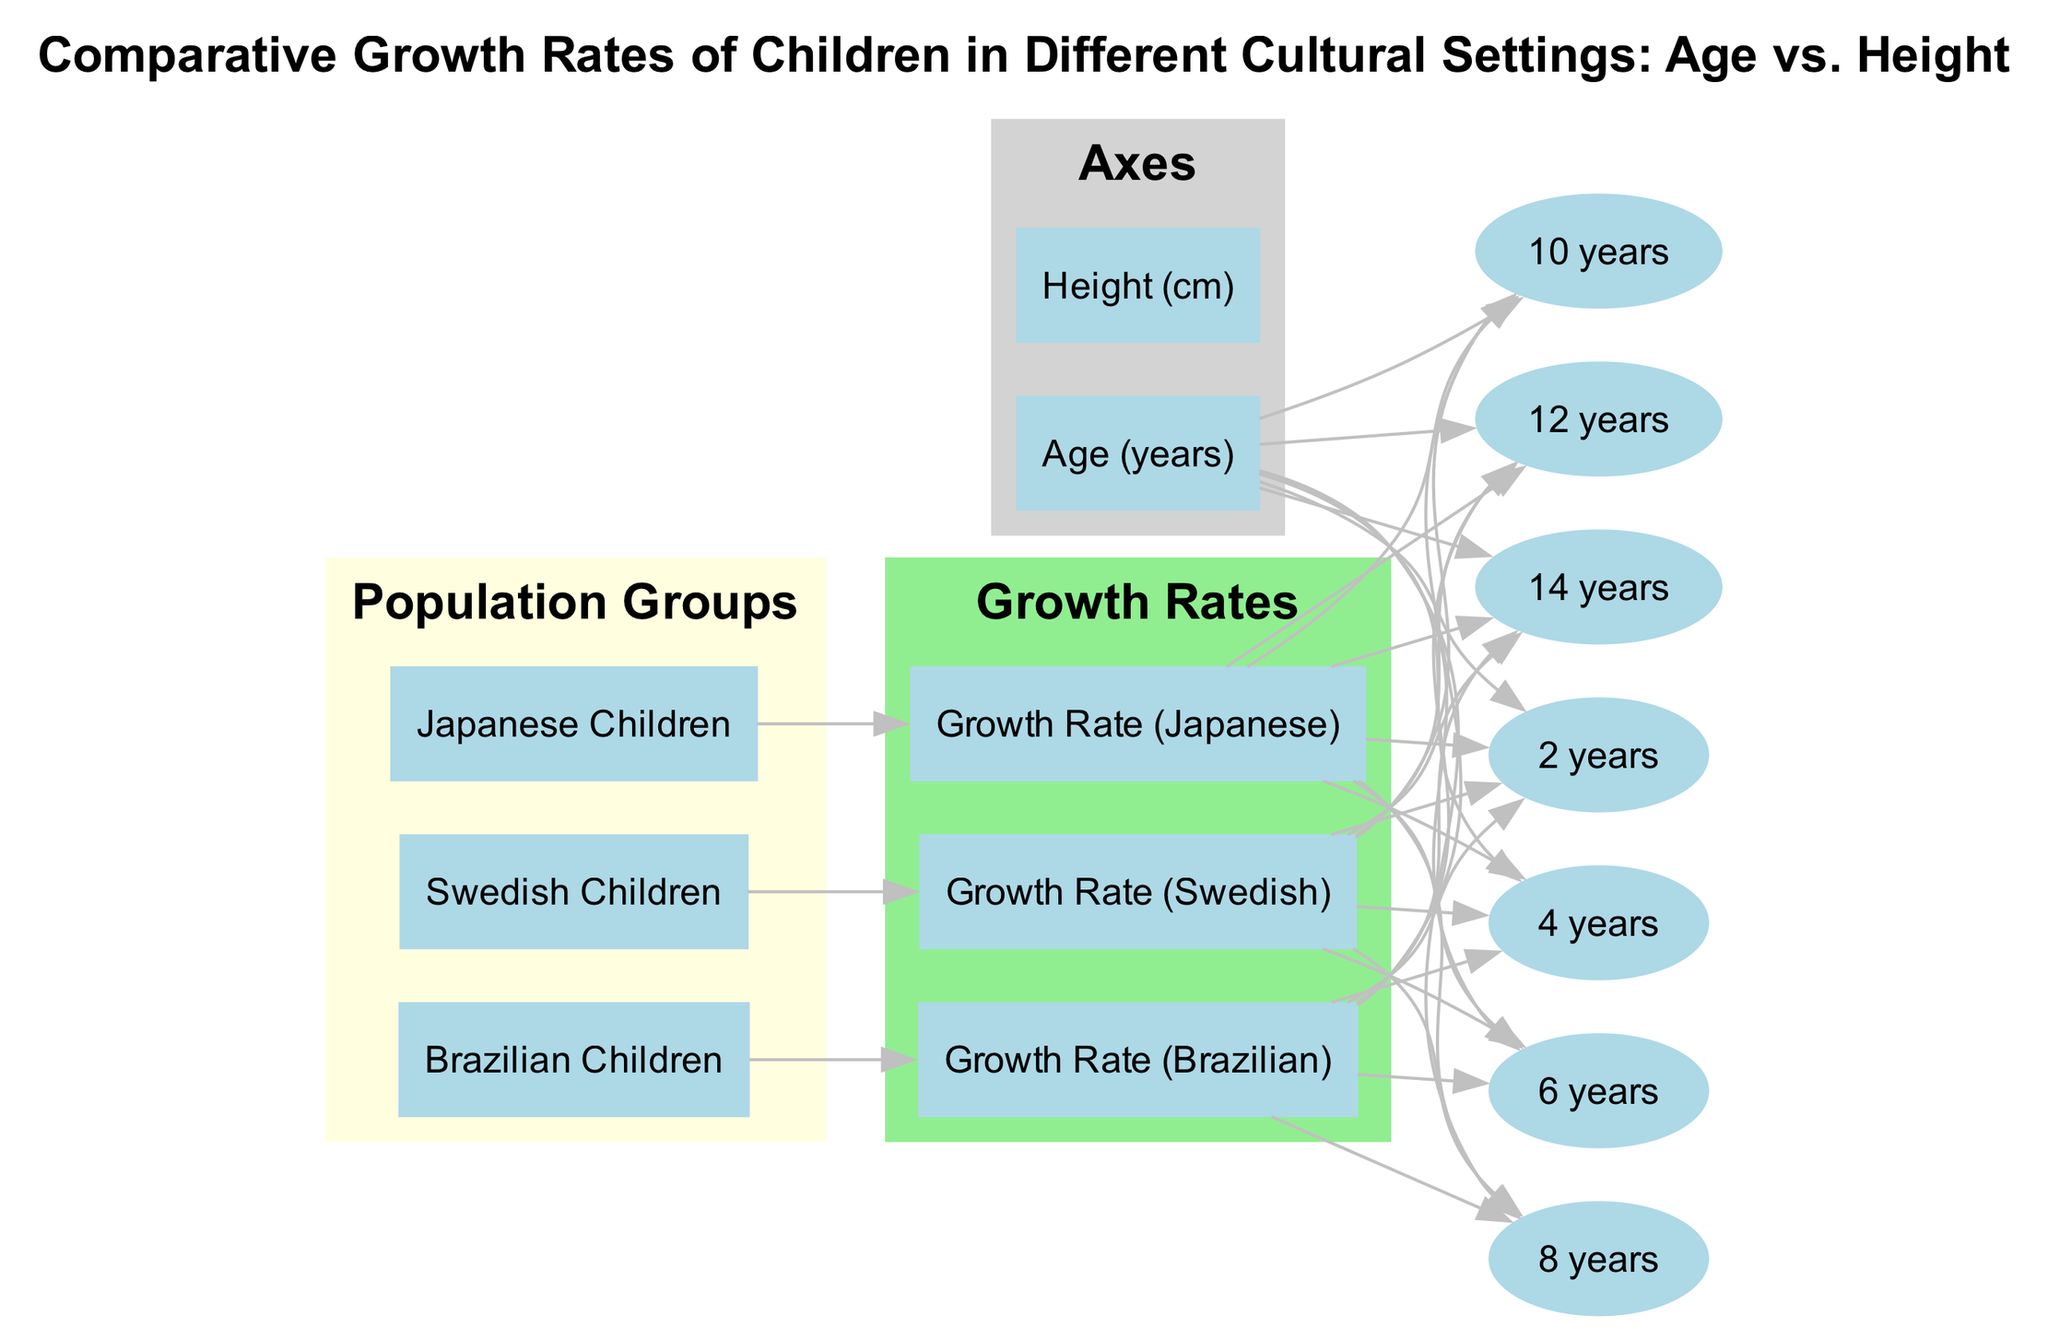What is the title of the diagram? The title of the diagram is located at the top of the diagram and is explicitly stated.
Answer: Comparative Growth Rates of Children in Different Cultural Settings: Age vs. Height How many population groups are represented? The diagram includes three distinct population groups: Japanese Children, Brazilian Children, and Swedish Children, which can be counted in the designated section.
Answer: 3 At what age is the height measurement for Brazilian children indicated? The age nodes connected to the growth rate of Brazilian children can be observed, showing various ages including 2, 4, 6, 8, 10, 12, and 14 years.
Answer: 2, 4, 6, 8, 10, 12, 14 Which growth rate corresponds to Swedish children? The growth rate labeled as "Growth Rate (Swedish)" is directly associated with the population group for Swedish children and can be identified in the growth rates section of the diagram.
Answer: Growth Rate (Swedish) Which cultural group has the highest growth rate at age 8? By analyzing the lines that connect the age node for 8 years to the growth rate nodes, we can compare the varying heights at age 8 for each population group and identify which one is the highest.
Answer: Not specified What descriptor connects age 10 with Japanese children? The age node of 10 years is linked through an edge to the growth rate of Japanese children, indicating a direct relationship that provides height information for that age.
Answer: Growth Rate (Japanese) Which age shows the lowest expected height for any population? By examining the age nodes and their corresponding connections togrowth rates, the lowest ages generally indicate the lowest heights, which can be confirmed by analyzing these relationships.
Answer: 2 years How many edges represent the growth rate of Japanese children? Counting the edges that connect the growth rate node of Japanese children to each respective age node will provide the total number of connections, indicating frequency.
Answer: 7 Which age increases the visibility of growth rates for Brazilian children? The edges connected to the growth rate for Brazilian children display significant growth at each designated age, thus we can identify which age shows the greatest growth when visually examining the connections.
Answer: 10 years 